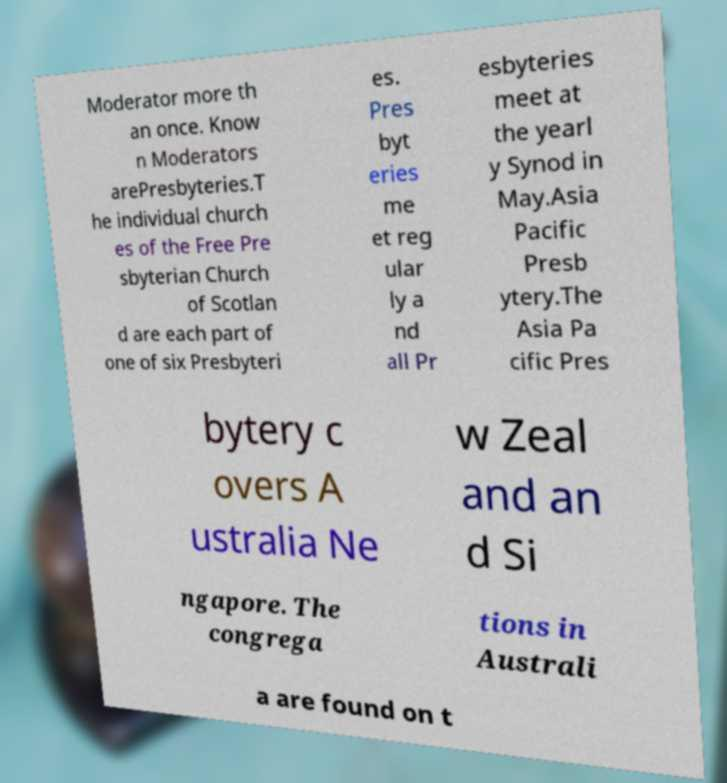Please identify and transcribe the text found in this image. Moderator more th an once. Know n Moderators arePresbyteries.T he individual church es of the Free Pre sbyterian Church of Scotlan d are each part of one of six Presbyteri es. Pres byt eries me et reg ular ly a nd all Pr esbyteries meet at the yearl y Synod in May.Asia Pacific Presb ytery.The Asia Pa cific Pres bytery c overs A ustralia Ne w Zeal and an d Si ngapore. The congrega tions in Australi a are found on t 